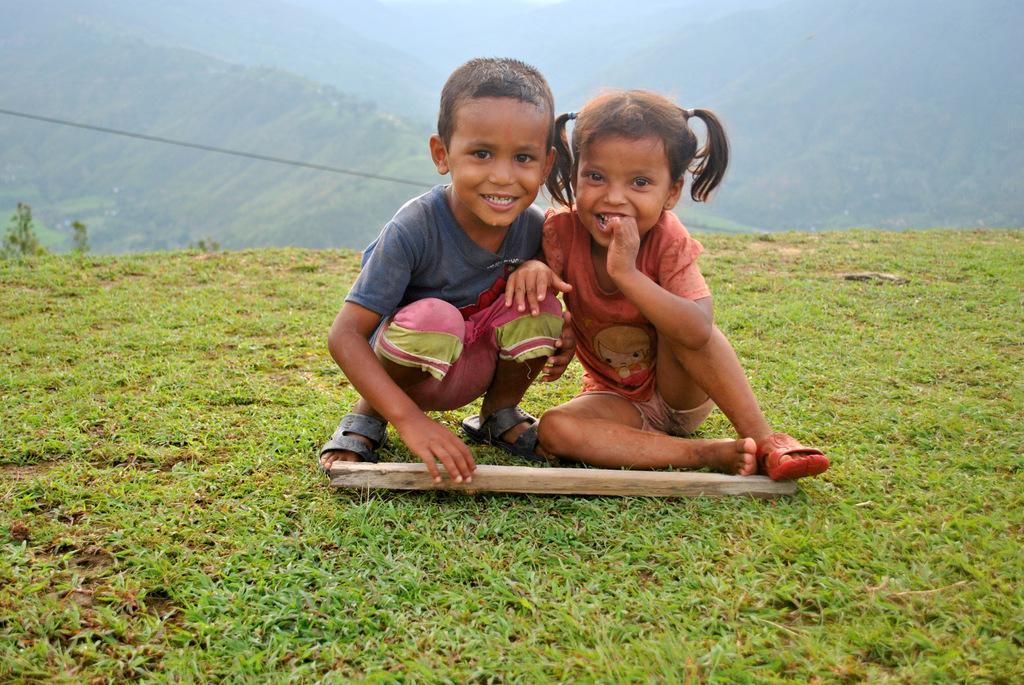Could you give a brief overview of what you see in this image? In this image there are two kids having a smile on their faces. In front of them there is a wooden stick. At the bottom of the image there is grass on the surface. In the background of the image there is a rope. There are mountains. 